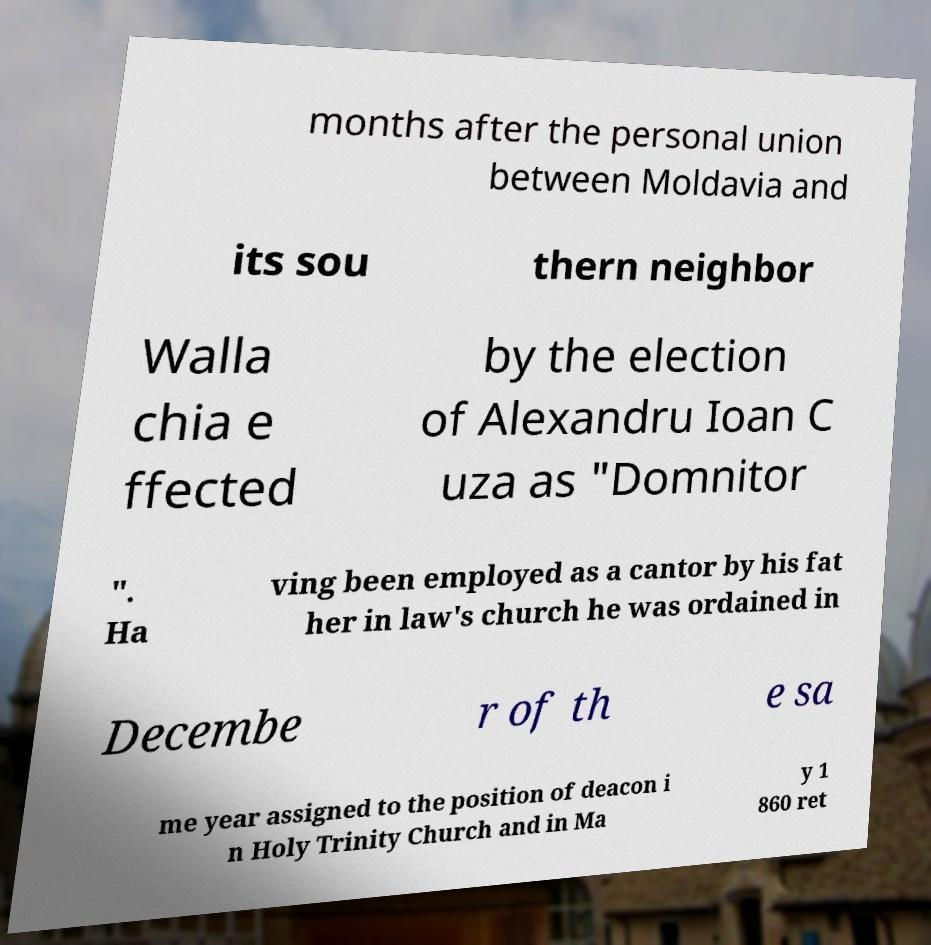Could you extract and type out the text from this image? months after the personal union between Moldavia and its sou thern neighbor Walla chia e ffected by the election of Alexandru Ioan C uza as "Domnitor ". Ha ving been employed as a cantor by his fat her in law's church he was ordained in Decembe r of th e sa me year assigned to the position of deacon i n Holy Trinity Church and in Ma y 1 860 ret 